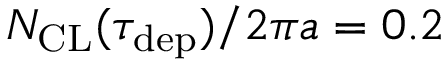Convert formula to latex. <formula><loc_0><loc_0><loc_500><loc_500>N _ { C L } ( \tau _ { d e p } ) / 2 \pi a = 0 . 2</formula> 